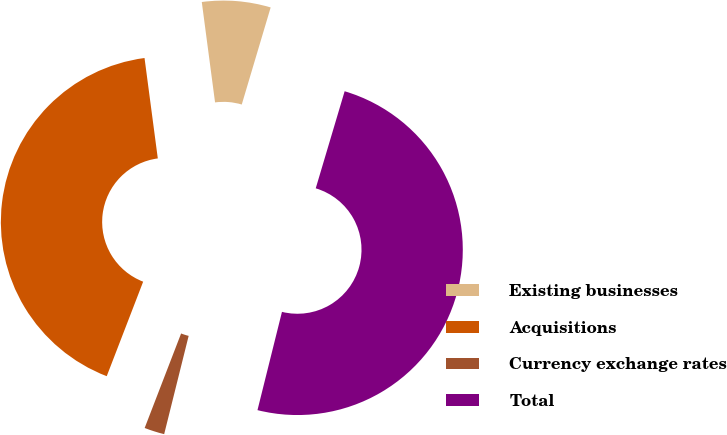<chart> <loc_0><loc_0><loc_500><loc_500><pie_chart><fcel>Existing businesses<fcel>Acquisitions<fcel>Currency exchange rates<fcel>Total<nl><fcel>6.7%<fcel>42.05%<fcel>1.97%<fcel>49.28%<nl></chart> 